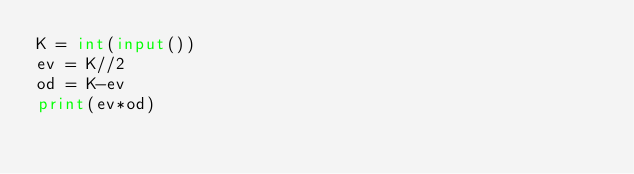<code> <loc_0><loc_0><loc_500><loc_500><_Python_>K = int(input())
ev = K//2
od = K-ev
print(ev*od)</code> 